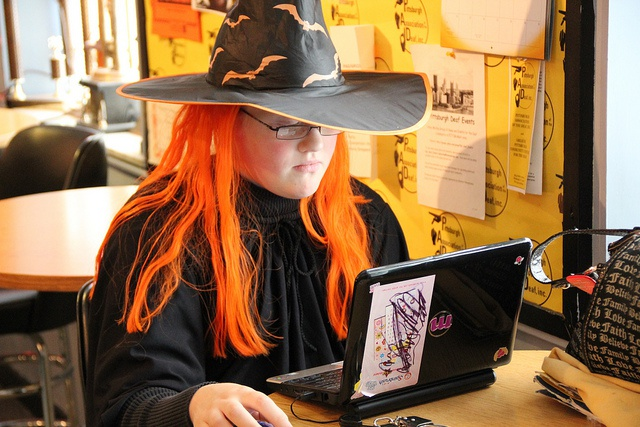Describe the objects in this image and their specific colors. I can see people in lightgray, black, red, maroon, and darkgray tones, laptop in lightgray, black, pink, and darkgray tones, dining table in lightgray, black, olive, and tan tones, handbag in lightgray, black, maroon, and gray tones, and dining table in lightgray, ivory, tan, brown, and orange tones in this image. 